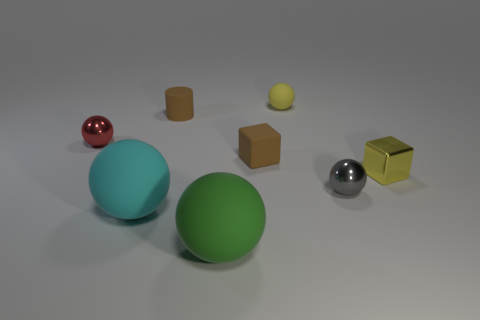Subtract all large cyan spheres. How many spheres are left? 4 Subtract all green balls. How many balls are left? 4 Subtract 1 spheres. How many spheres are left? 4 Add 1 gray metallic things. How many objects exist? 9 Subtract all brown spheres. Subtract all green blocks. How many spheres are left? 5 Subtract all cubes. How many objects are left? 6 Subtract all cyan balls. Subtract all tiny cylinders. How many objects are left? 6 Add 4 small yellow matte objects. How many small yellow matte objects are left? 5 Add 4 small yellow matte objects. How many small yellow matte objects exist? 5 Subtract 0 cyan cylinders. How many objects are left? 8 